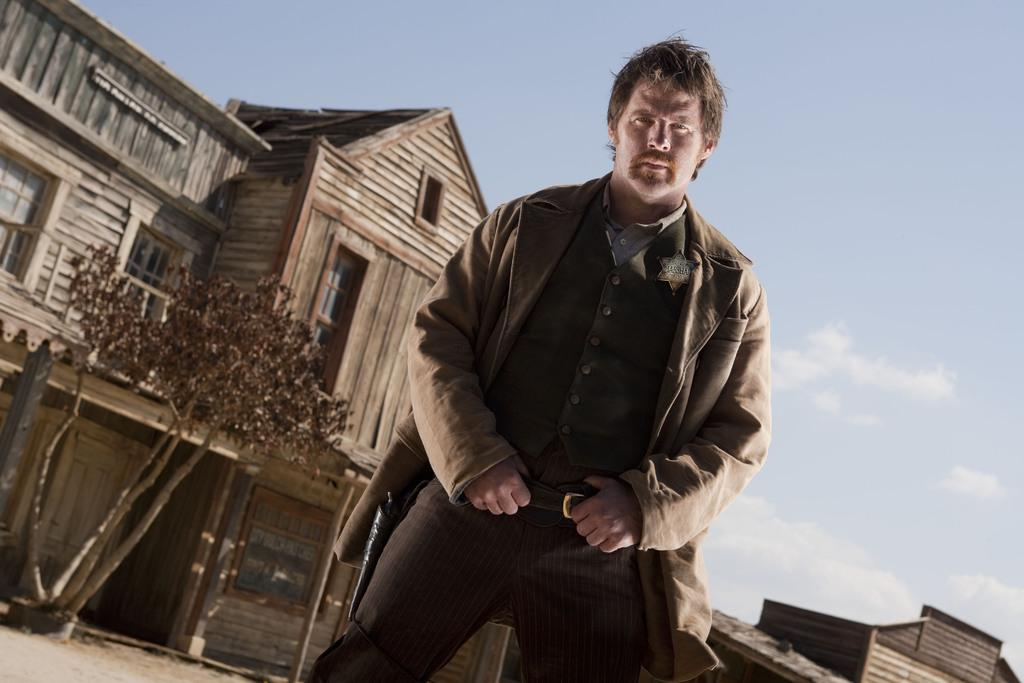Where was the image taken? The image was clicked outside. What is the main subject in the foreground of the image? There is a man in the foreground of the image. What is the man wearing in the image? The man is wearing a jacket. What is the man doing in the image? The man is standing. What can be seen in the background of the image? There is sky, houses, a tree, and other objects visible in the background of the image. How many cows are visible in the image? There are no cows present in the image. What attempt is the man making in the image? The image does not depict any specific attempt or action by the man, other than standing. 